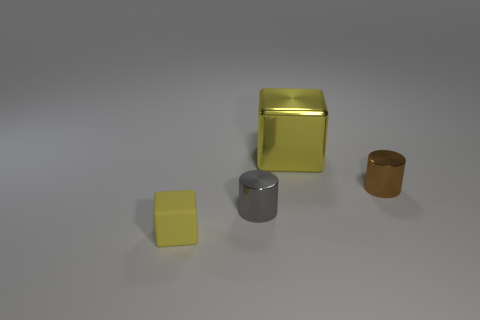What might be the purpose of this arrangement, and what feeling does it evoke? The arrangement appears to be intentional, with a focus on geometric shapes and a variety of colors, which could suggest a study in shapes and textures for an art piece or a visual composition exercise. The orderly placement of objects and soft lighting evokes a sense of calm and order, reflecting a simplistic and minimalist aesthetic. 